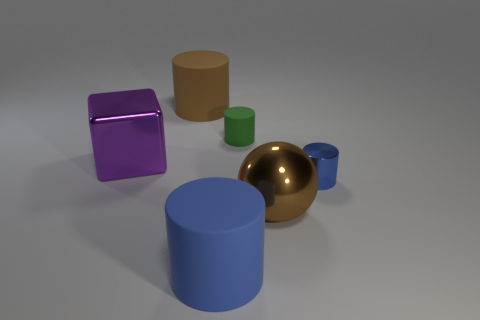Add 1 big blue cylinders. How many objects exist? 7 Subtract all cylinders. How many objects are left? 2 Subtract 0 blue spheres. How many objects are left? 6 Subtract all big purple blocks. Subtract all blocks. How many objects are left? 4 Add 6 metallic cubes. How many metallic cubes are left? 7 Add 6 blue rubber cylinders. How many blue rubber cylinders exist? 7 